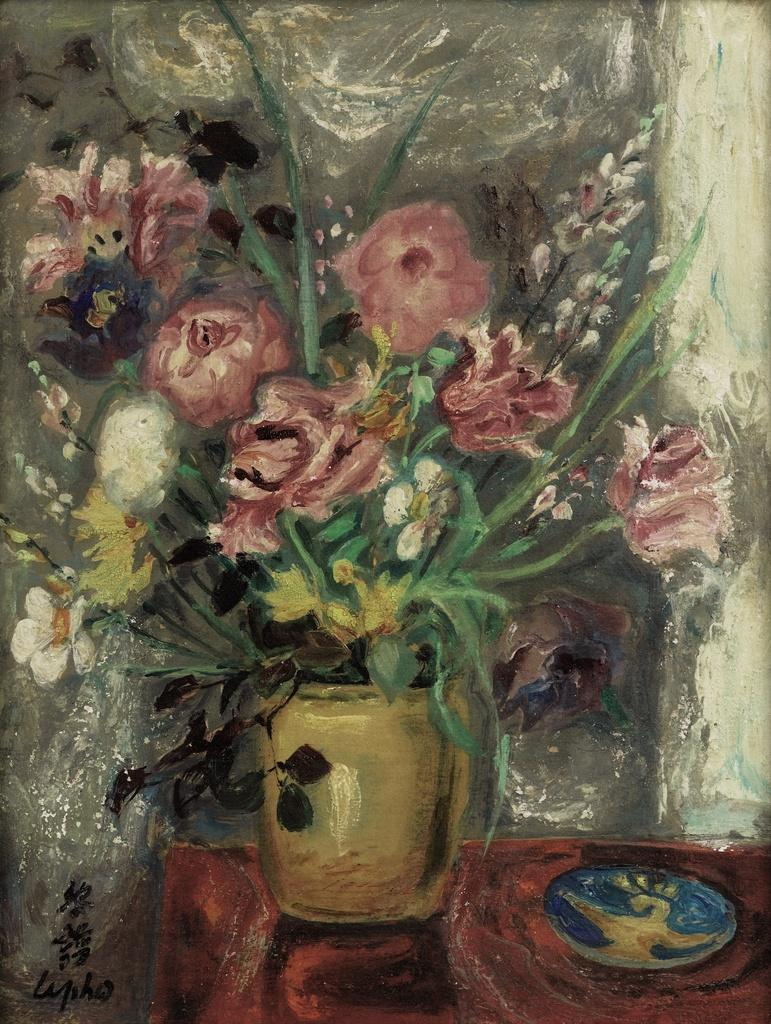What is the main subject of the image? There is a painting in the image. What is depicted in the painting? The painting contains a flower pot. Where is the flower pot located within the painting? The flower pot is on a table. Can you see a squirrel climbing the volcano in the painting? There is no squirrel or volcano present in the painting; it only contains a flower pot on a table. 